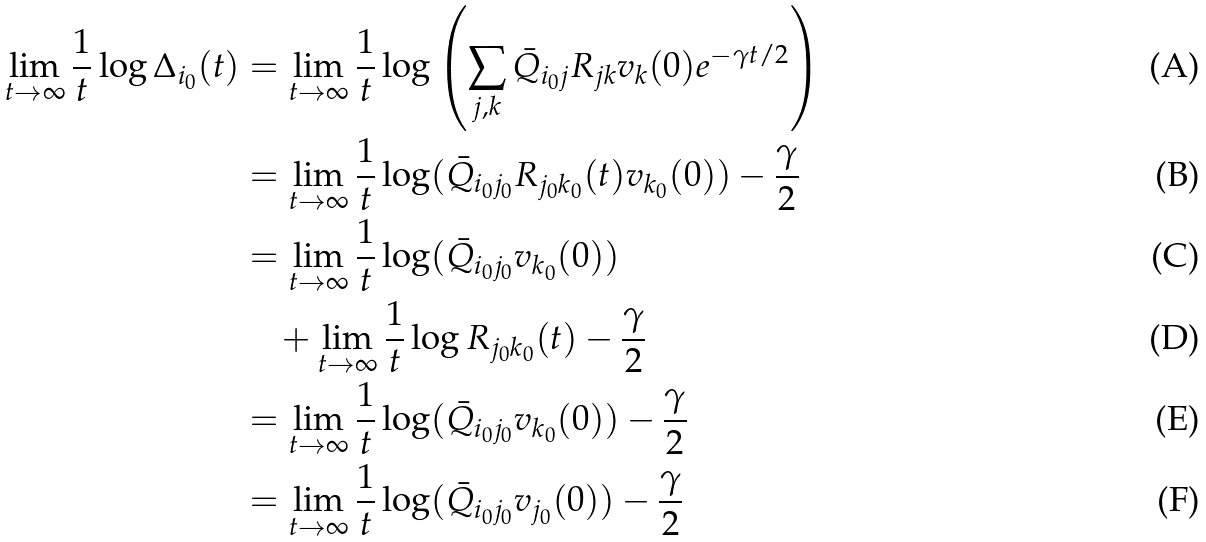Convert formula to latex. <formula><loc_0><loc_0><loc_500><loc_500>\lim _ { t \to \infty } \frac { 1 } { t } \log \Delta _ { i _ { 0 } } ( t ) & = \lim _ { t \to \infty } \frac { 1 } { t } \log \left ( \sum _ { j , k } \bar { Q } _ { i _ { 0 } j } R _ { j k } v _ { k } ( 0 ) e ^ { - \gamma t / 2 } \right ) \\ & = \lim _ { t \to \infty } \frac { 1 } { t } \log ( \bar { Q } _ { i _ { 0 } j _ { 0 } } R _ { j _ { 0 } k _ { 0 } } ( t ) v _ { k _ { 0 } } ( 0 ) ) - \frac { \gamma } { 2 } \\ & = \lim _ { t \to \infty } \frac { 1 } { t } \log ( \bar { Q } _ { i _ { 0 } j _ { 0 } } v _ { k _ { 0 } } ( 0 ) ) \\ & \quad + \lim _ { t \to \infty } \frac { 1 } { t } \log R _ { j _ { 0 } k _ { 0 } } ( t ) - \frac { \gamma } { 2 } \\ & = \lim _ { t \to \infty } \frac { 1 } { t } \log ( \bar { Q } _ { i _ { 0 } j _ { 0 } } v _ { k _ { 0 } } ( 0 ) ) - \frac { \gamma } { 2 } \\ & = \lim _ { t \to \infty } \frac { 1 } { t } \log ( \bar { Q } _ { i _ { 0 } j _ { 0 } } v _ { j _ { 0 } } ( 0 ) ) - \frac { \gamma } { 2 }</formula> 